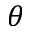Convert formula to latex. <formula><loc_0><loc_0><loc_500><loc_500>\theta</formula> 